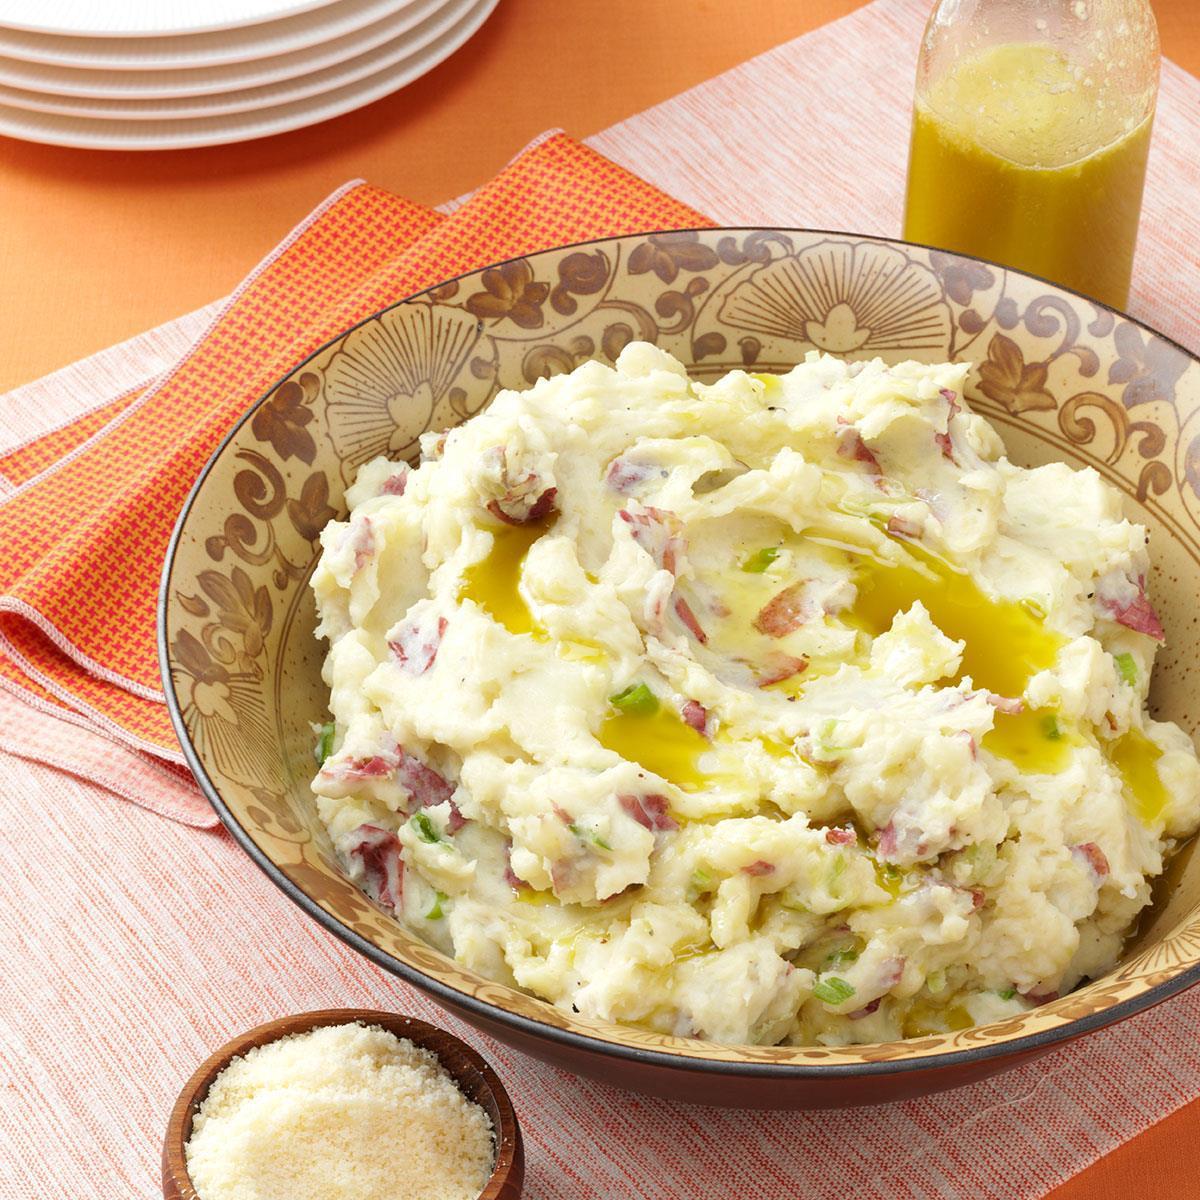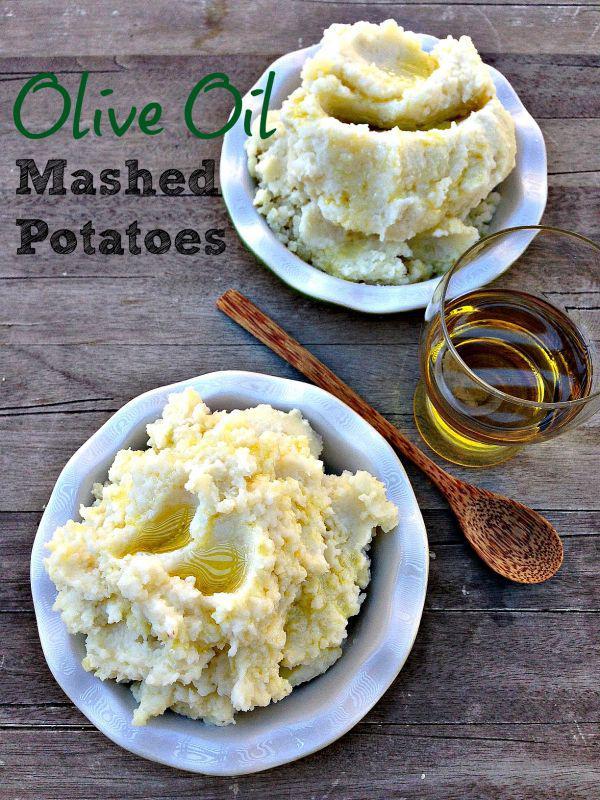The first image is the image on the left, the second image is the image on the right. Evaluate the accuracy of this statement regarding the images: "Each image shows one round bowl with potatoes and some type of silver utensil in it, and one image features a white bowl with a spoon in mashed potatoes.". Is it true? Answer yes or no. No. The first image is the image on the left, the second image is the image on the right. Considering the images on both sides, is "The left and right image contains the same number of fully mashed potatoes bowls with spoons." valid? Answer yes or no. No. 